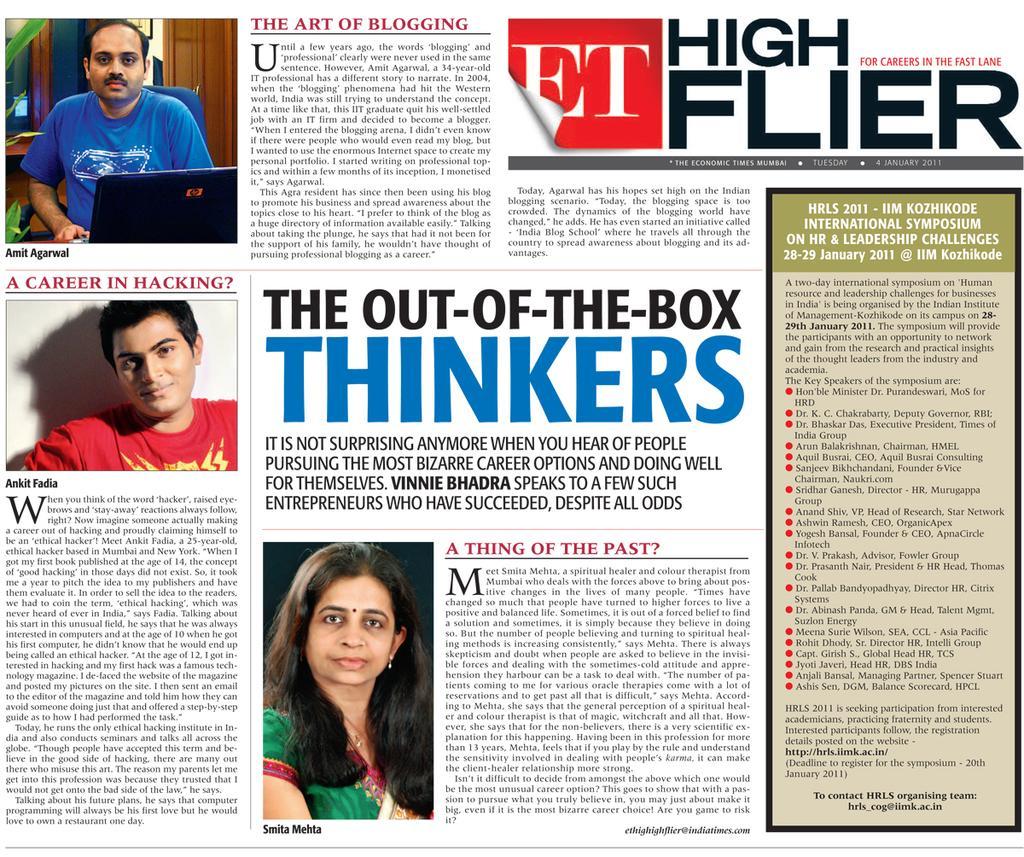Please provide a concise description of this image. This is a poster. In this poster there are images of people. Also there is something written. In the left top corner there is a person sitting on a chair. Also there is a laptop. 